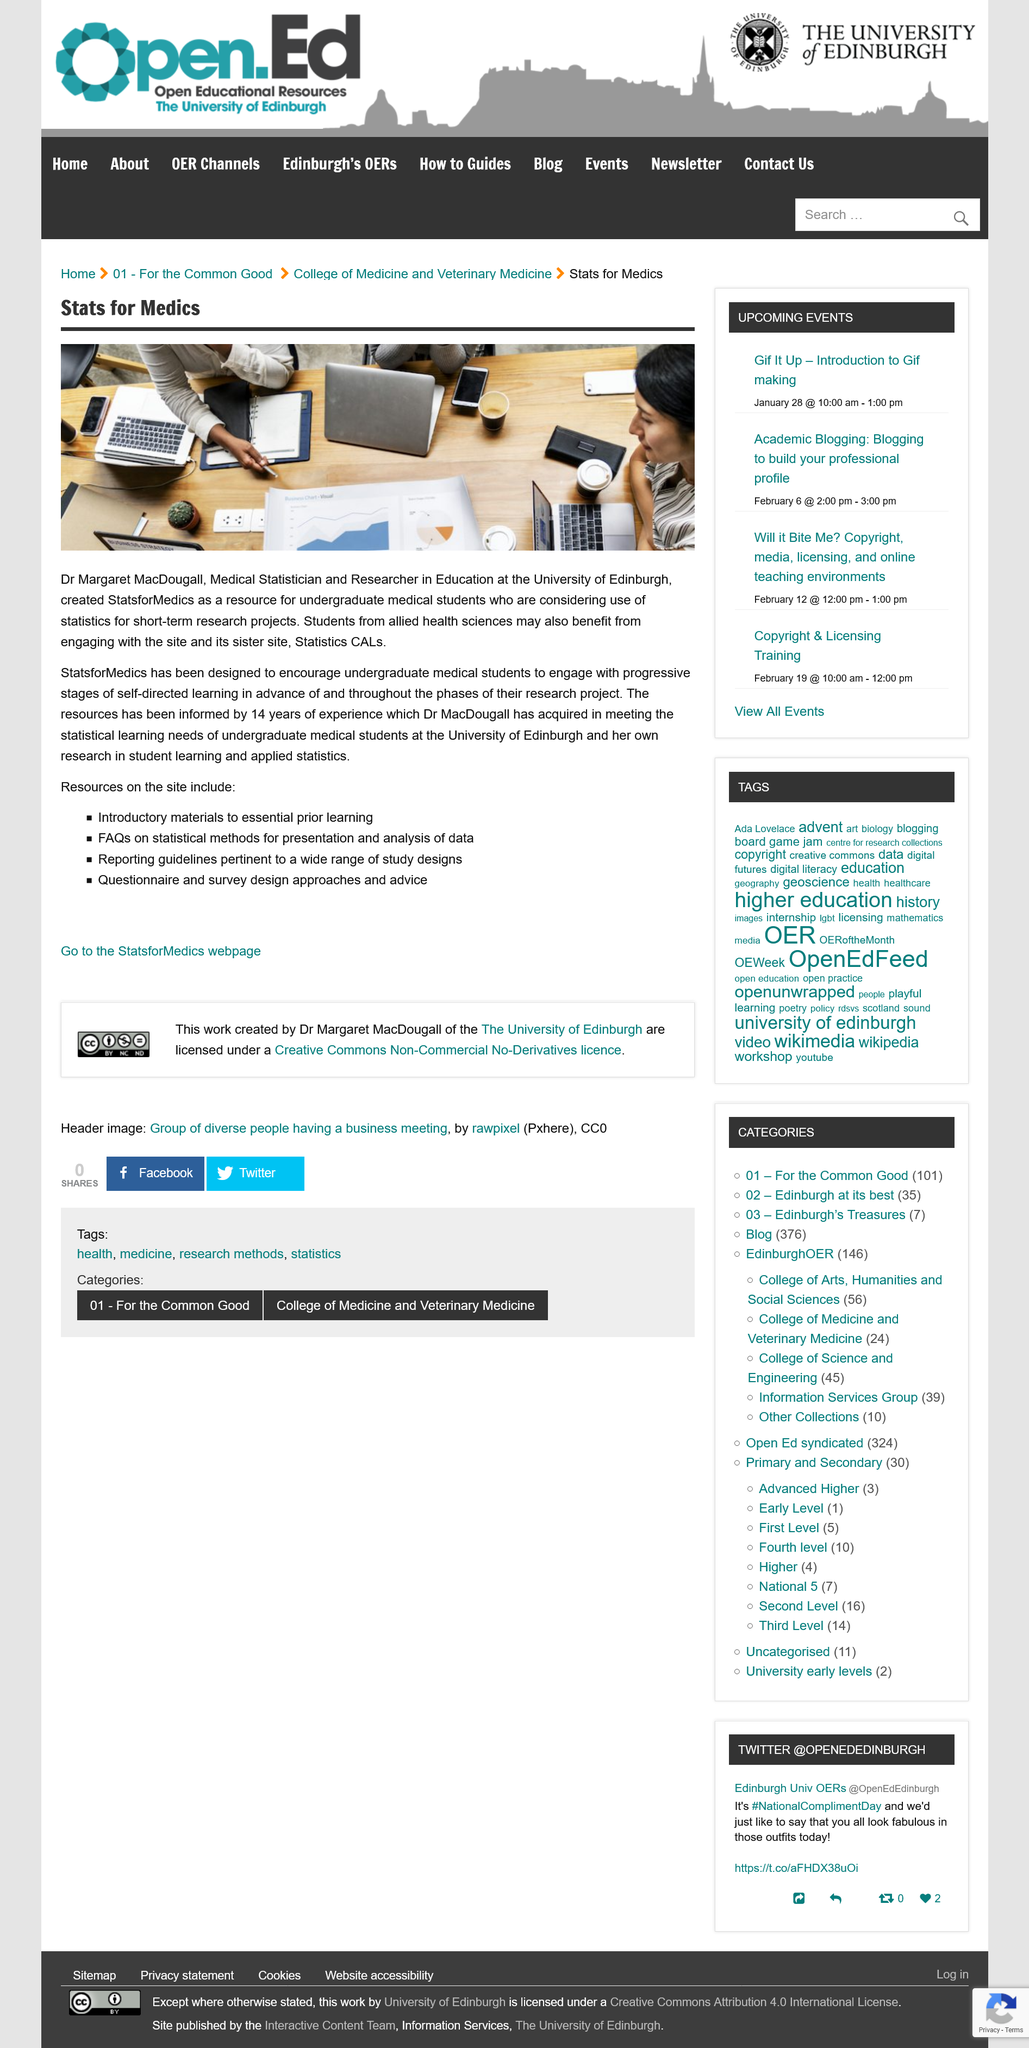Mention a couple of crucial points in this snapshot. StatsforMedics is a software designed to assist medical students in their research projects by providing them with a platform to engage with statistics and self-learning. Dr. MacDougall has a total of 14 years of experience. StatsforMedics was created by Dr. Margaret MacDougall. 